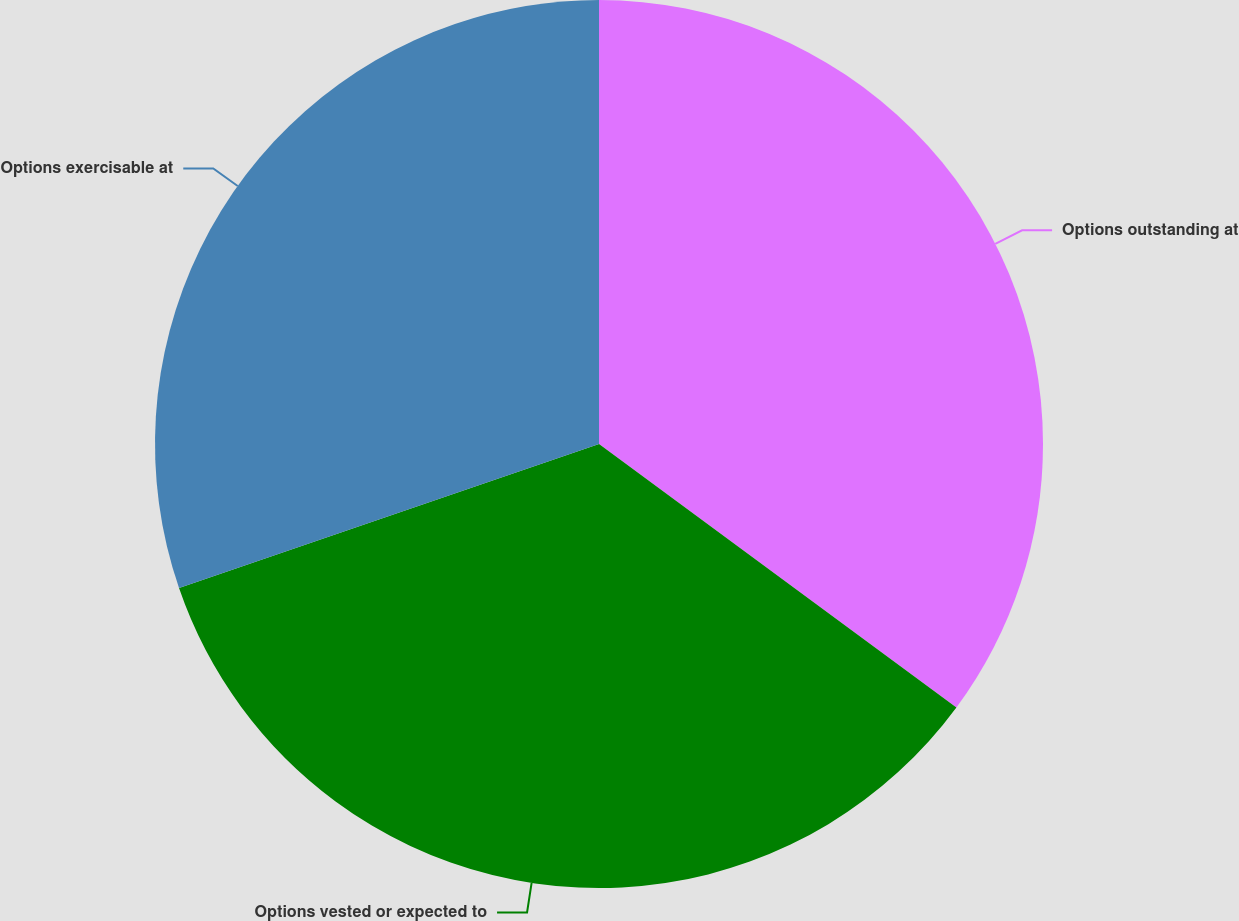Convert chart to OTSL. <chart><loc_0><loc_0><loc_500><loc_500><pie_chart><fcel>Options outstanding at<fcel>Options vested or expected to<fcel>Options exercisable at<nl><fcel>35.11%<fcel>34.63%<fcel>30.26%<nl></chart> 